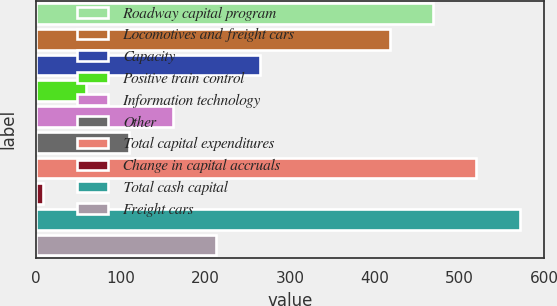<chart> <loc_0><loc_0><loc_500><loc_500><bar_chart><fcel>Roadway capital program<fcel>Locomotives and freight cars<fcel>Capacity<fcel>Positive train control<fcel>Information technology<fcel>Other<fcel>Total capital expenditures<fcel>Change in capital accruals<fcel>Total cash capital<fcel>Freight cars<nl><fcel>469.07<fcel>417.84<fcel>264.15<fcel>59.23<fcel>161.69<fcel>110.46<fcel>520.3<fcel>8<fcel>571.53<fcel>212.92<nl></chart> 